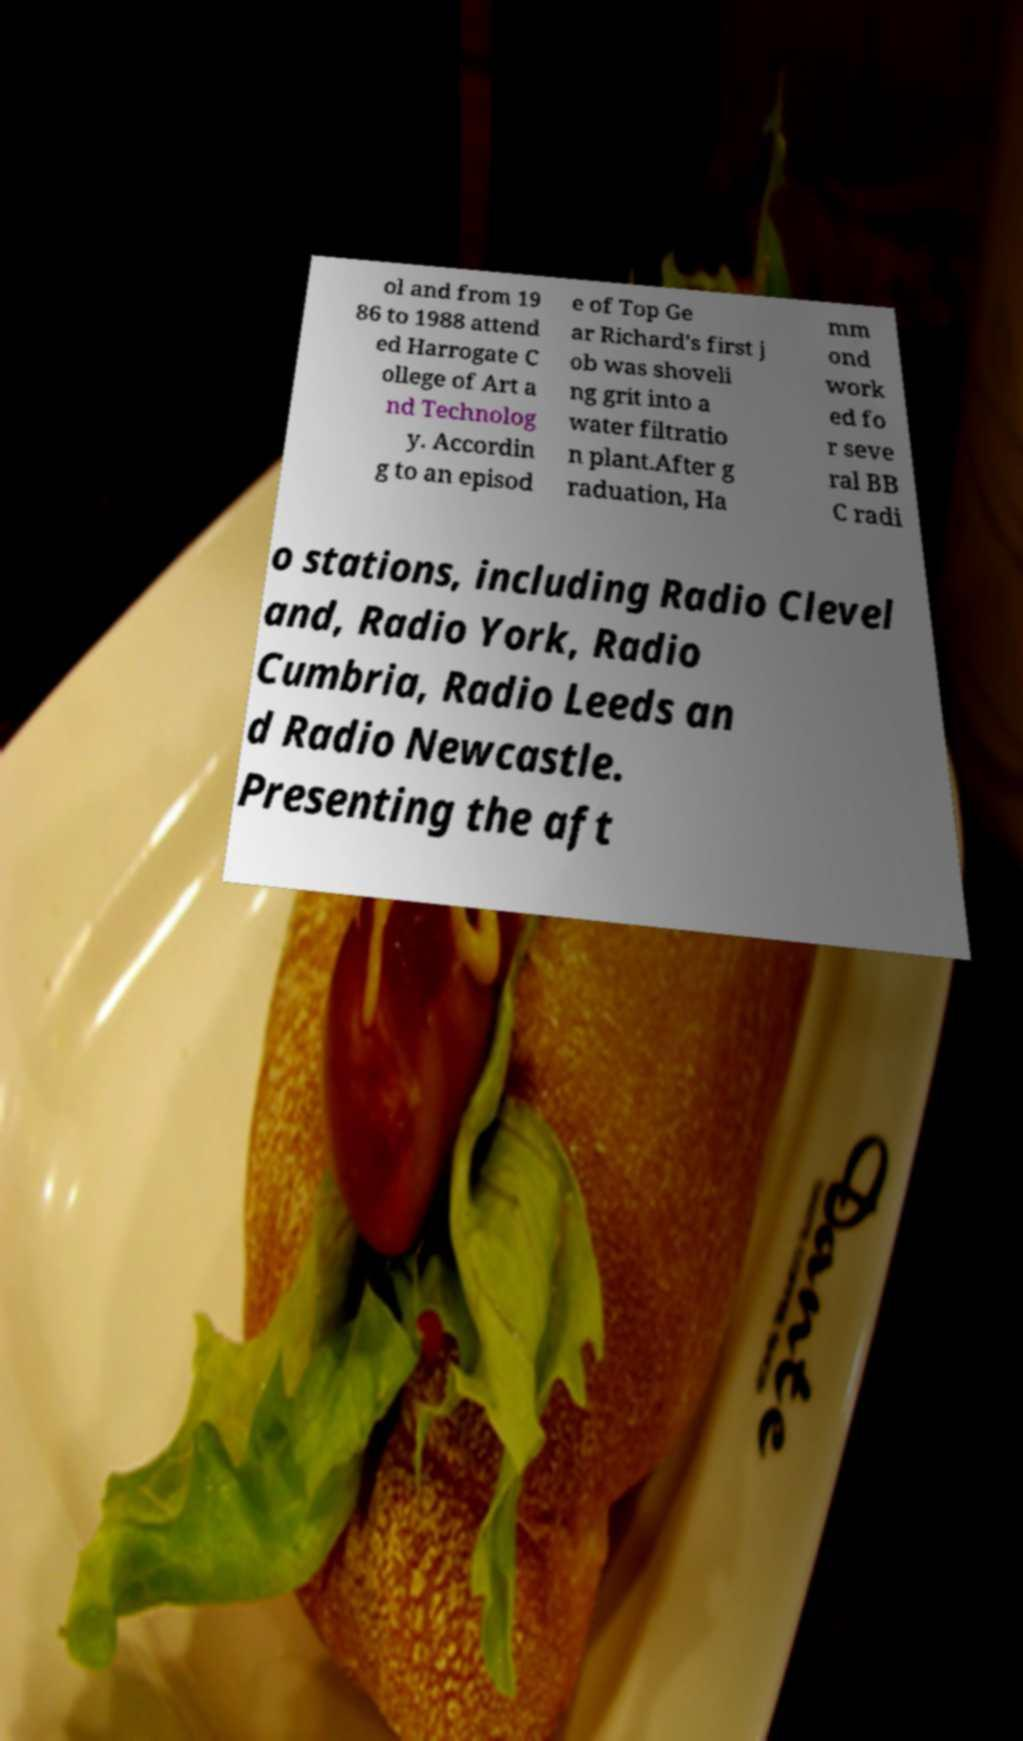There's text embedded in this image that I need extracted. Can you transcribe it verbatim? ol and from 19 86 to 1988 attend ed Harrogate C ollege of Art a nd Technolog y. Accordin g to an episod e of Top Ge ar Richard's first j ob was shoveli ng grit into a water filtratio n plant.After g raduation, Ha mm ond work ed fo r seve ral BB C radi o stations, including Radio Clevel and, Radio York, Radio Cumbria, Radio Leeds an d Radio Newcastle. Presenting the aft 